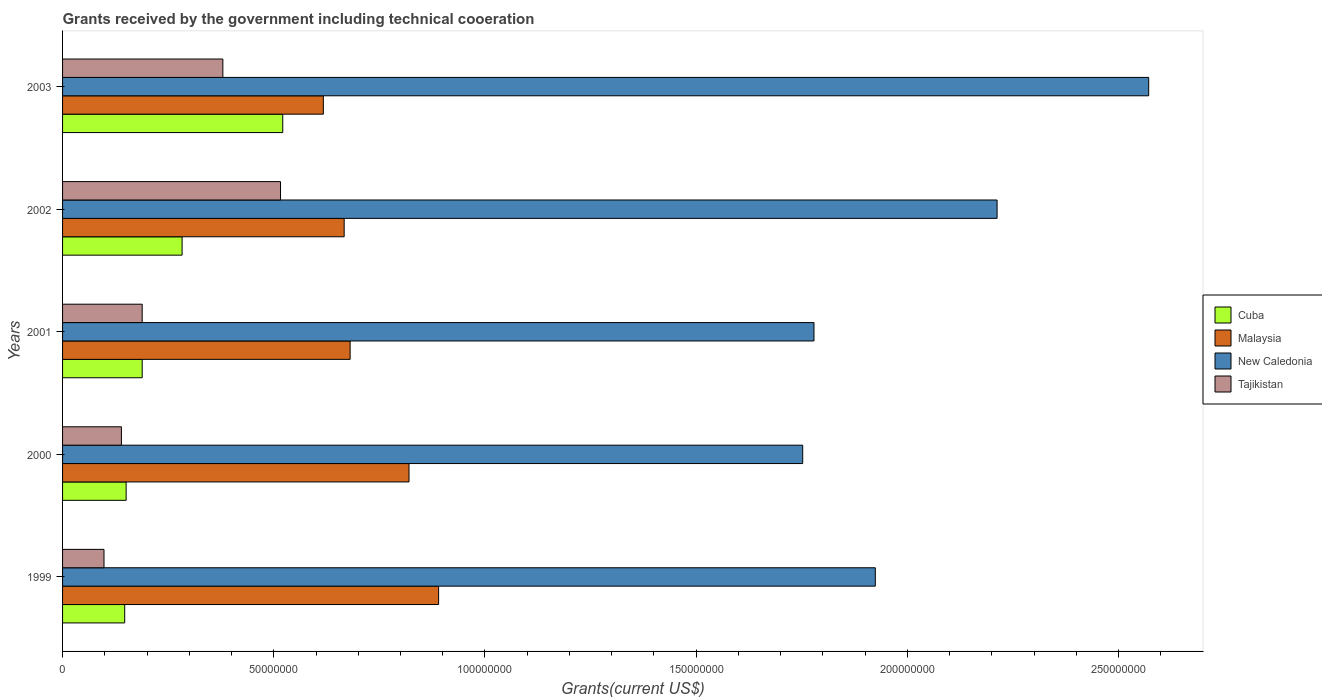How many different coloured bars are there?
Make the answer very short. 4. How many groups of bars are there?
Make the answer very short. 5. Are the number of bars on each tick of the Y-axis equal?
Offer a very short reply. Yes. How many bars are there on the 5th tick from the bottom?
Provide a short and direct response. 4. What is the label of the 4th group of bars from the top?
Your answer should be very brief. 2000. What is the total grants received by the government in New Caledonia in 2002?
Offer a terse response. 2.21e+08. Across all years, what is the maximum total grants received by the government in Tajikistan?
Provide a succinct answer. 5.16e+07. Across all years, what is the minimum total grants received by the government in New Caledonia?
Make the answer very short. 1.75e+08. In which year was the total grants received by the government in New Caledonia maximum?
Offer a terse response. 2003. In which year was the total grants received by the government in Malaysia minimum?
Your answer should be very brief. 2003. What is the total total grants received by the government in Tajikistan in the graph?
Offer a very short reply. 1.32e+08. What is the difference between the total grants received by the government in New Caledonia in 1999 and that in 2002?
Provide a short and direct response. -2.88e+07. What is the difference between the total grants received by the government in Malaysia in 1999 and the total grants received by the government in New Caledonia in 2002?
Your answer should be compact. -1.32e+08. What is the average total grants received by the government in Tajikistan per year?
Provide a succinct answer. 2.64e+07. In the year 1999, what is the difference between the total grants received by the government in Tajikistan and total grants received by the government in Cuba?
Your response must be concise. -4.90e+06. What is the ratio of the total grants received by the government in Tajikistan in 2000 to that in 2002?
Offer a very short reply. 0.27. Is the total grants received by the government in Malaysia in 2001 less than that in 2002?
Provide a succinct answer. No. What is the difference between the highest and the second highest total grants received by the government in Cuba?
Keep it short and to the point. 2.38e+07. What is the difference between the highest and the lowest total grants received by the government in Malaysia?
Keep it short and to the point. 2.73e+07. In how many years, is the total grants received by the government in Cuba greater than the average total grants received by the government in Cuba taken over all years?
Offer a terse response. 2. Is it the case that in every year, the sum of the total grants received by the government in Malaysia and total grants received by the government in New Caledonia is greater than the sum of total grants received by the government in Tajikistan and total grants received by the government in Cuba?
Your answer should be compact. Yes. What does the 1st bar from the top in 2000 represents?
Your answer should be compact. Tajikistan. What does the 4th bar from the bottom in 1999 represents?
Make the answer very short. Tajikistan. What is the difference between two consecutive major ticks on the X-axis?
Make the answer very short. 5.00e+07. What is the title of the graph?
Your answer should be very brief. Grants received by the government including technical cooeration. What is the label or title of the X-axis?
Offer a terse response. Grants(current US$). What is the label or title of the Y-axis?
Provide a succinct answer. Years. What is the Grants(current US$) of Cuba in 1999?
Offer a very short reply. 1.47e+07. What is the Grants(current US$) in Malaysia in 1999?
Offer a terse response. 8.90e+07. What is the Grants(current US$) of New Caledonia in 1999?
Your answer should be compact. 1.92e+08. What is the Grants(current US$) of Tajikistan in 1999?
Your answer should be very brief. 9.81e+06. What is the Grants(current US$) of Cuba in 2000?
Provide a succinct answer. 1.50e+07. What is the Grants(current US$) in Malaysia in 2000?
Give a very brief answer. 8.20e+07. What is the Grants(current US$) of New Caledonia in 2000?
Give a very brief answer. 1.75e+08. What is the Grants(current US$) of Tajikistan in 2000?
Ensure brevity in your answer.  1.39e+07. What is the Grants(current US$) of Cuba in 2001?
Provide a short and direct response. 1.88e+07. What is the Grants(current US$) of Malaysia in 2001?
Provide a short and direct response. 6.81e+07. What is the Grants(current US$) of New Caledonia in 2001?
Offer a terse response. 1.78e+08. What is the Grants(current US$) in Tajikistan in 2001?
Offer a very short reply. 1.88e+07. What is the Grants(current US$) of Cuba in 2002?
Give a very brief answer. 2.83e+07. What is the Grants(current US$) of Malaysia in 2002?
Provide a succinct answer. 6.67e+07. What is the Grants(current US$) in New Caledonia in 2002?
Give a very brief answer. 2.21e+08. What is the Grants(current US$) in Tajikistan in 2002?
Your answer should be compact. 5.16e+07. What is the Grants(current US$) in Cuba in 2003?
Ensure brevity in your answer.  5.21e+07. What is the Grants(current US$) in Malaysia in 2003?
Give a very brief answer. 6.17e+07. What is the Grants(current US$) in New Caledonia in 2003?
Make the answer very short. 2.57e+08. What is the Grants(current US$) in Tajikistan in 2003?
Give a very brief answer. 3.80e+07. Across all years, what is the maximum Grants(current US$) in Cuba?
Your answer should be very brief. 5.21e+07. Across all years, what is the maximum Grants(current US$) in Malaysia?
Provide a short and direct response. 8.90e+07. Across all years, what is the maximum Grants(current US$) of New Caledonia?
Provide a short and direct response. 2.57e+08. Across all years, what is the maximum Grants(current US$) of Tajikistan?
Provide a short and direct response. 5.16e+07. Across all years, what is the minimum Grants(current US$) in Cuba?
Provide a short and direct response. 1.47e+07. Across all years, what is the minimum Grants(current US$) of Malaysia?
Make the answer very short. 6.17e+07. Across all years, what is the minimum Grants(current US$) in New Caledonia?
Offer a very short reply. 1.75e+08. Across all years, what is the minimum Grants(current US$) in Tajikistan?
Provide a succinct answer. 9.81e+06. What is the total Grants(current US$) in Cuba in the graph?
Your answer should be compact. 1.29e+08. What is the total Grants(current US$) in Malaysia in the graph?
Your answer should be very brief. 3.68e+08. What is the total Grants(current US$) of New Caledonia in the graph?
Keep it short and to the point. 1.02e+09. What is the total Grants(current US$) of Tajikistan in the graph?
Provide a succinct answer. 1.32e+08. What is the difference between the Grants(current US$) of Malaysia in 1999 and that in 2000?
Provide a succinct answer. 7.01e+06. What is the difference between the Grants(current US$) of New Caledonia in 1999 and that in 2000?
Offer a very short reply. 1.72e+07. What is the difference between the Grants(current US$) of Tajikistan in 1999 and that in 2000?
Keep it short and to the point. -4.12e+06. What is the difference between the Grants(current US$) of Cuba in 1999 and that in 2001?
Ensure brevity in your answer.  -4.14e+06. What is the difference between the Grants(current US$) in Malaysia in 1999 and that in 2001?
Provide a succinct answer. 2.10e+07. What is the difference between the Grants(current US$) of New Caledonia in 1999 and that in 2001?
Make the answer very short. 1.45e+07. What is the difference between the Grants(current US$) in Tajikistan in 1999 and that in 2001?
Make the answer very short. -9.04e+06. What is the difference between the Grants(current US$) in Cuba in 1999 and that in 2002?
Give a very brief answer. -1.36e+07. What is the difference between the Grants(current US$) in Malaysia in 1999 and that in 2002?
Offer a terse response. 2.24e+07. What is the difference between the Grants(current US$) in New Caledonia in 1999 and that in 2002?
Ensure brevity in your answer.  -2.88e+07. What is the difference between the Grants(current US$) of Tajikistan in 1999 and that in 2002?
Ensure brevity in your answer.  -4.18e+07. What is the difference between the Grants(current US$) of Cuba in 1999 and that in 2003?
Offer a very short reply. -3.74e+07. What is the difference between the Grants(current US$) in Malaysia in 1999 and that in 2003?
Ensure brevity in your answer.  2.73e+07. What is the difference between the Grants(current US$) of New Caledonia in 1999 and that in 2003?
Ensure brevity in your answer.  -6.47e+07. What is the difference between the Grants(current US$) in Tajikistan in 1999 and that in 2003?
Offer a very short reply. -2.81e+07. What is the difference between the Grants(current US$) in Cuba in 2000 and that in 2001?
Provide a succinct answer. -3.80e+06. What is the difference between the Grants(current US$) in Malaysia in 2000 and that in 2001?
Offer a terse response. 1.39e+07. What is the difference between the Grants(current US$) in New Caledonia in 2000 and that in 2001?
Your answer should be compact. -2.67e+06. What is the difference between the Grants(current US$) of Tajikistan in 2000 and that in 2001?
Provide a short and direct response. -4.92e+06. What is the difference between the Grants(current US$) in Cuba in 2000 and that in 2002?
Your answer should be compact. -1.32e+07. What is the difference between the Grants(current US$) in Malaysia in 2000 and that in 2002?
Ensure brevity in your answer.  1.54e+07. What is the difference between the Grants(current US$) in New Caledonia in 2000 and that in 2002?
Your answer should be very brief. -4.60e+07. What is the difference between the Grants(current US$) of Tajikistan in 2000 and that in 2002?
Ensure brevity in your answer.  -3.77e+07. What is the difference between the Grants(current US$) of Cuba in 2000 and that in 2003?
Offer a very short reply. -3.71e+07. What is the difference between the Grants(current US$) of Malaysia in 2000 and that in 2003?
Provide a short and direct response. 2.03e+07. What is the difference between the Grants(current US$) in New Caledonia in 2000 and that in 2003?
Your answer should be very brief. -8.19e+07. What is the difference between the Grants(current US$) in Tajikistan in 2000 and that in 2003?
Provide a short and direct response. -2.40e+07. What is the difference between the Grants(current US$) in Cuba in 2001 and that in 2002?
Your response must be concise. -9.45e+06. What is the difference between the Grants(current US$) of Malaysia in 2001 and that in 2002?
Provide a short and direct response. 1.41e+06. What is the difference between the Grants(current US$) of New Caledonia in 2001 and that in 2002?
Offer a very short reply. -4.34e+07. What is the difference between the Grants(current US$) of Tajikistan in 2001 and that in 2002?
Give a very brief answer. -3.28e+07. What is the difference between the Grants(current US$) of Cuba in 2001 and that in 2003?
Offer a terse response. -3.33e+07. What is the difference between the Grants(current US$) in Malaysia in 2001 and that in 2003?
Your response must be concise. 6.34e+06. What is the difference between the Grants(current US$) of New Caledonia in 2001 and that in 2003?
Your answer should be compact. -7.92e+07. What is the difference between the Grants(current US$) in Tajikistan in 2001 and that in 2003?
Offer a very short reply. -1.91e+07. What is the difference between the Grants(current US$) of Cuba in 2002 and that in 2003?
Ensure brevity in your answer.  -2.38e+07. What is the difference between the Grants(current US$) in Malaysia in 2002 and that in 2003?
Make the answer very short. 4.93e+06. What is the difference between the Grants(current US$) in New Caledonia in 2002 and that in 2003?
Your answer should be compact. -3.59e+07. What is the difference between the Grants(current US$) in Tajikistan in 2002 and that in 2003?
Give a very brief answer. 1.36e+07. What is the difference between the Grants(current US$) of Cuba in 1999 and the Grants(current US$) of Malaysia in 2000?
Give a very brief answer. -6.73e+07. What is the difference between the Grants(current US$) in Cuba in 1999 and the Grants(current US$) in New Caledonia in 2000?
Offer a very short reply. -1.61e+08. What is the difference between the Grants(current US$) of Cuba in 1999 and the Grants(current US$) of Tajikistan in 2000?
Make the answer very short. 7.80e+05. What is the difference between the Grants(current US$) in Malaysia in 1999 and the Grants(current US$) in New Caledonia in 2000?
Provide a short and direct response. -8.62e+07. What is the difference between the Grants(current US$) of Malaysia in 1999 and the Grants(current US$) of Tajikistan in 2000?
Provide a short and direct response. 7.51e+07. What is the difference between the Grants(current US$) in New Caledonia in 1999 and the Grants(current US$) in Tajikistan in 2000?
Give a very brief answer. 1.78e+08. What is the difference between the Grants(current US$) of Cuba in 1999 and the Grants(current US$) of Malaysia in 2001?
Keep it short and to the point. -5.34e+07. What is the difference between the Grants(current US$) of Cuba in 1999 and the Grants(current US$) of New Caledonia in 2001?
Ensure brevity in your answer.  -1.63e+08. What is the difference between the Grants(current US$) of Cuba in 1999 and the Grants(current US$) of Tajikistan in 2001?
Offer a terse response. -4.14e+06. What is the difference between the Grants(current US$) in Malaysia in 1999 and the Grants(current US$) in New Caledonia in 2001?
Give a very brief answer. -8.89e+07. What is the difference between the Grants(current US$) of Malaysia in 1999 and the Grants(current US$) of Tajikistan in 2001?
Offer a terse response. 7.02e+07. What is the difference between the Grants(current US$) of New Caledonia in 1999 and the Grants(current US$) of Tajikistan in 2001?
Provide a succinct answer. 1.74e+08. What is the difference between the Grants(current US$) of Cuba in 1999 and the Grants(current US$) of Malaysia in 2002?
Ensure brevity in your answer.  -5.20e+07. What is the difference between the Grants(current US$) in Cuba in 1999 and the Grants(current US$) in New Caledonia in 2002?
Your answer should be very brief. -2.07e+08. What is the difference between the Grants(current US$) in Cuba in 1999 and the Grants(current US$) in Tajikistan in 2002?
Your answer should be compact. -3.69e+07. What is the difference between the Grants(current US$) of Malaysia in 1999 and the Grants(current US$) of New Caledonia in 2002?
Provide a short and direct response. -1.32e+08. What is the difference between the Grants(current US$) of Malaysia in 1999 and the Grants(current US$) of Tajikistan in 2002?
Offer a very short reply. 3.74e+07. What is the difference between the Grants(current US$) of New Caledonia in 1999 and the Grants(current US$) of Tajikistan in 2002?
Ensure brevity in your answer.  1.41e+08. What is the difference between the Grants(current US$) of Cuba in 1999 and the Grants(current US$) of Malaysia in 2003?
Provide a succinct answer. -4.70e+07. What is the difference between the Grants(current US$) of Cuba in 1999 and the Grants(current US$) of New Caledonia in 2003?
Offer a very short reply. -2.42e+08. What is the difference between the Grants(current US$) of Cuba in 1999 and the Grants(current US$) of Tajikistan in 2003?
Offer a terse response. -2.32e+07. What is the difference between the Grants(current US$) in Malaysia in 1999 and the Grants(current US$) in New Caledonia in 2003?
Offer a terse response. -1.68e+08. What is the difference between the Grants(current US$) of Malaysia in 1999 and the Grants(current US$) of Tajikistan in 2003?
Make the answer very short. 5.11e+07. What is the difference between the Grants(current US$) of New Caledonia in 1999 and the Grants(current US$) of Tajikistan in 2003?
Keep it short and to the point. 1.54e+08. What is the difference between the Grants(current US$) in Cuba in 2000 and the Grants(current US$) in Malaysia in 2001?
Keep it short and to the point. -5.30e+07. What is the difference between the Grants(current US$) of Cuba in 2000 and the Grants(current US$) of New Caledonia in 2001?
Offer a terse response. -1.63e+08. What is the difference between the Grants(current US$) of Cuba in 2000 and the Grants(current US$) of Tajikistan in 2001?
Offer a very short reply. -3.80e+06. What is the difference between the Grants(current US$) of Malaysia in 2000 and the Grants(current US$) of New Caledonia in 2001?
Offer a very short reply. -9.59e+07. What is the difference between the Grants(current US$) in Malaysia in 2000 and the Grants(current US$) in Tajikistan in 2001?
Make the answer very short. 6.32e+07. What is the difference between the Grants(current US$) of New Caledonia in 2000 and the Grants(current US$) of Tajikistan in 2001?
Make the answer very short. 1.56e+08. What is the difference between the Grants(current US$) of Cuba in 2000 and the Grants(current US$) of Malaysia in 2002?
Ensure brevity in your answer.  -5.16e+07. What is the difference between the Grants(current US$) of Cuba in 2000 and the Grants(current US$) of New Caledonia in 2002?
Your answer should be very brief. -2.06e+08. What is the difference between the Grants(current US$) in Cuba in 2000 and the Grants(current US$) in Tajikistan in 2002?
Your response must be concise. -3.66e+07. What is the difference between the Grants(current US$) in Malaysia in 2000 and the Grants(current US$) in New Caledonia in 2002?
Your answer should be compact. -1.39e+08. What is the difference between the Grants(current US$) of Malaysia in 2000 and the Grants(current US$) of Tajikistan in 2002?
Offer a terse response. 3.04e+07. What is the difference between the Grants(current US$) in New Caledonia in 2000 and the Grants(current US$) in Tajikistan in 2002?
Your answer should be very brief. 1.24e+08. What is the difference between the Grants(current US$) in Cuba in 2000 and the Grants(current US$) in Malaysia in 2003?
Provide a succinct answer. -4.67e+07. What is the difference between the Grants(current US$) of Cuba in 2000 and the Grants(current US$) of New Caledonia in 2003?
Provide a succinct answer. -2.42e+08. What is the difference between the Grants(current US$) in Cuba in 2000 and the Grants(current US$) in Tajikistan in 2003?
Your response must be concise. -2.29e+07. What is the difference between the Grants(current US$) of Malaysia in 2000 and the Grants(current US$) of New Caledonia in 2003?
Provide a short and direct response. -1.75e+08. What is the difference between the Grants(current US$) in Malaysia in 2000 and the Grants(current US$) in Tajikistan in 2003?
Provide a short and direct response. 4.41e+07. What is the difference between the Grants(current US$) of New Caledonia in 2000 and the Grants(current US$) of Tajikistan in 2003?
Make the answer very short. 1.37e+08. What is the difference between the Grants(current US$) of Cuba in 2001 and the Grants(current US$) of Malaysia in 2002?
Provide a succinct answer. -4.78e+07. What is the difference between the Grants(current US$) in Cuba in 2001 and the Grants(current US$) in New Caledonia in 2002?
Your response must be concise. -2.02e+08. What is the difference between the Grants(current US$) in Cuba in 2001 and the Grants(current US$) in Tajikistan in 2002?
Your answer should be compact. -3.28e+07. What is the difference between the Grants(current US$) in Malaysia in 2001 and the Grants(current US$) in New Caledonia in 2002?
Provide a short and direct response. -1.53e+08. What is the difference between the Grants(current US$) of Malaysia in 2001 and the Grants(current US$) of Tajikistan in 2002?
Keep it short and to the point. 1.65e+07. What is the difference between the Grants(current US$) of New Caledonia in 2001 and the Grants(current US$) of Tajikistan in 2002?
Your answer should be compact. 1.26e+08. What is the difference between the Grants(current US$) in Cuba in 2001 and the Grants(current US$) in Malaysia in 2003?
Offer a very short reply. -4.29e+07. What is the difference between the Grants(current US$) in Cuba in 2001 and the Grants(current US$) in New Caledonia in 2003?
Your answer should be compact. -2.38e+08. What is the difference between the Grants(current US$) of Cuba in 2001 and the Grants(current US$) of Tajikistan in 2003?
Provide a short and direct response. -1.91e+07. What is the difference between the Grants(current US$) of Malaysia in 2001 and the Grants(current US$) of New Caledonia in 2003?
Make the answer very short. -1.89e+08. What is the difference between the Grants(current US$) of Malaysia in 2001 and the Grants(current US$) of Tajikistan in 2003?
Ensure brevity in your answer.  3.01e+07. What is the difference between the Grants(current US$) of New Caledonia in 2001 and the Grants(current US$) of Tajikistan in 2003?
Give a very brief answer. 1.40e+08. What is the difference between the Grants(current US$) of Cuba in 2002 and the Grants(current US$) of Malaysia in 2003?
Provide a succinct answer. -3.34e+07. What is the difference between the Grants(current US$) in Cuba in 2002 and the Grants(current US$) in New Caledonia in 2003?
Offer a very short reply. -2.29e+08. What is the difference between the Grants(current US$) in Cuba in 2002 and the Grants(current US$) in Tajikistan in 2003?
Provide a succinct answer. -9.65e+06. What is the difference between the Grants(current US$) of Malaysia in 2002 and the Grants(current US$) of New Caledonia in 2003?
Offer a terse response. -1.90e+08. What is the difference between the Grants(current US$) in Malaysia in 2002 and the Grants(current US$) in Tajikistan in 2003?
Keep it short and to the point. 2.87e+07. What is the difference between the Grants(current US$) of New Caledonia in 2002 and the Grants(current US$) of Tajikistan in 2003?
Provide a short and direct response. 1.83e+08. What is the average Grants(current US$) of Cuba per year?
Your answer should be compact. 2.58e+07. What is the average Grants(current US$) in Malaysia per year?
Your response must be concise. 7.35e+07. What is the average Grants(current US$) in New Caledonia per year?
Provide a succinct answer. 2.05e+08. What is the average Grants(current US$) in Tajikistan per year?
Your answer should be very brief. 2.64e+07. In the year 1999, what is the difference between the Grants(current US$) in Cuba and Grants(current US$) in Malaysia?
Offer a very short reply. -7.43e+07. In the year 1999, what is the difference between the Grants(current US$) in Cuba and Grants(current US$) in New Caledonia?
Your answer should be compact. -1.78e+08. In the year 1999, what is the difference between the Grants(current US$) in Cuba and Grants(current US$) in Tajikistan?
Offer a terse response. 4.90e+06. In the year 1999, what is the difference between the Grants(current US$) in Malaysia and Grants(current US$) in New Caledonia?
Ensure brevity in your answer.  -1.03e+08. In the year 1999, what is the difference between the Grants(current US$) in Malaysia and Grants(current US$) in Tajikistan?
Provide a short and direct response. 7.92e+07. In the year 1999, what is the difference between the Grants(current US$) of New Caledonia and Grants(current US$) of Tajikistan?
Keep it short and to the point. 1.83e+08. In the year 2000, what is the difference between the Grants(current US$) in Cuba and Grants(current US$) in Malaysia?
Provide a succinct answer. -6.70e+07. In the year 2000, what is the difference between the Grants(current US$) of Cuba and Grants(current US$) of New Caledonia?
Provide a succinct answer. -1.60e+08. In the year 2000, what is the difference between the Grants(current US$) of Cuba and Grants(current US$) of Tajikistan?
Make the answer very short. 1.12e+06. In the year 2000, what is the difference between the Grants(current US$) of Malaysia and Grants(current US$) of New Caledonia?
Provide a succinct answer. -9.32e+07. In the year 2000, what is the difference between the Grants(current US$) in Malaysia and Grants(current US$) in Tajikistan?
Make the answer very short. 6.81e+07. In the year 2000, what is the difference between the Grants(current US$) of New Caledonia and Grants(current US$) of Tajikistan?
Provide a short and direct response. 1.61e+08. In the year 2001, what is the difference between the Grants(current US$) in Cuba and Grants(current US$) in Malaysia?
Keep it short and to the point. -4.92e+07. In the year 2001, what is the difference between the Grants(current US$) in Cuba and Grants(current US$) in New Caledonia?
Your answer should be very brief. -1.59e+08. In the year 2001, what is the difference between the Grants(current US$) of Malaysia and Grants(current US$) of New Caledonia?
Offer a very short reply. -1.10e+08. In the year 2001, what is the difference between the Grants(current US$) in Malaysia and Grants(current US$) in Tajikistan?
Provide a succinct answer. 4.92e+07. In the year 2001, what is the difference between the Grants(current US$) of New Caledonia and Grants(current US$) of Tajikistan?
Give a very brief answer. 1.59e+08. In the year 2002, what is the difference between the Grants(current US$) of Cuba and Grants(current US$) of Malaysia?
Ensure brevity in your answer.  -3.84e+07. In the year 2002, what is the difference between the Grants(current US$) in Cuba and Grants(current US$) in New Caledonia?
Give a very brief answer. -1.93e+08. In the year 2002, what is the difference between the Grants(current US$) of Cuba and Grants(current US$) of Tajikistan?
Offer a very short reply. -2.33e+07. In the year 2002, what is the difference between the Grants(current US$) of Malaysia and Grants(current US$) of New Caledonia?
Your answer should be compact. -1.55e+08. In the year 2002, what is the difference between the Grants(current US$) of Malaysia and Grants(current US$) of Tajikistan?
Offer a terse response. 1.51e+07. In the year 2002, what is the difference between the Grants(current US$) in New Caledonia and Grants(current US$) in Tajikistan?
Make the answer very short. 1.70e+08. In the year 2003, what is the difference between the Grants(current US$) in Cuba and Grants(current US$) in Malaysia?
Ensure brevity in your answer.  -9.61e+06. In the year 2003, what is the difference between the Grants(current US$) in Cuba and Grants(current US$) in New Caledonia?
Give a very brief answer. -2.05e+08. In the year 2003, what is the difference between the Grants(current US$) in Cuba and Grants(current US$) in Tajikistan?
Ensure brevity in your answer.  1.42e+07. In the year 2003, what is the difference between the Grants(current US$) of Malaysia and Grants(current US$) of New Caledonia?
Give a very brief answer. -1.95e+08. In the year 2003, what is the difference between the Grants(current US$) of Malaysia and Grants(current US$) of Tajikistan?
Your answer should be very brief. 2.38e+07. In the year 2003, what is the difference between the Grants(current US$) in New Caledonia and Grants(current US$) in Tajikistan?
Give a very brief answer. 2.19e+08. What is the ratio of the Grants(current US$) in Cuba in 1999 to that in 2000?
Your answer should be very brief. 0.98. What is the ratio of the Grants(current US$) in Malaysia in 1999 to that in 2000?
Offer a terse response. 1.09. What is the ratio of the Grants(current US$) in New Caledonia in 1999 to that in 2000?
Keep it short and to the point. 1.1. What is the ratio of the Grants(current US$) in Tajikistan in 1999 to that in 2000?
Provide a short and direct response. 0.7. What is the ratio of the Grants(current US$) of Cuba in 1999 to that in 2001?
Give a very brief answer. 0.78. What is the ratio of the Grants(current US$) in Malaysia in 1999 to that in 2001?
Offer a terse response. 1.31. What is the ratio of the Grants(current US$) in New Caledonia in 1999 to that in 2001?
Keep it short and to the point. 1.08. What is the ratio of the Grants(current US$) in Tajikistan in 1999 to that in 2001?
Offer a terse response. 0.52. What is the ratio of the Grants(current US$) of Cuba in 1999 to that in 2002?
Keep it short and to the point. 0.52. What is the ratio of the Grants(current US$) in Malaysia in 1999 to that in 2002?
Make the answer very short. 1.34. What is the ratio of the Grants(current US$) of New Caledonia in 1999 to that in 2002?
Provide a short and direct response. 0.87. What is the ratio of the Grants(current US$) of Tajikistan in 1999 to that in 2002?
Your answer should be very brief. 0.19. What is the ratio of the Grants(current US$) in Cuba in 1999 to that in 2003?
Your answer should be compact. 0.28. What is the ratio of the Grants(current US$) in Malaysia in 1999 to that in 2003?
Give a very brief answer. 1.44. What is the ratio of the Grants(current US$) of New Caledonia in 1999 to that in 2003?
Provide a short and direct response. 0.75. What is the ratio of the Grants(current US$) of Tajikistan in 1999 to that in 2003?
Your response must be concise. 0.26. What is the ratio of the Grants(current US$) of Cuba in 2000 to that in 2001?
Give a very brief answer. 0.8. What is the ratio of the Grants(current US$) of Malaysia in 2000 to that in 2001?
Your response must be concise. 1.2. What is the ratio of the Grants(current US$) in Tajikistan in 2000 to that in 2001?
Provide a succinct answer. 0.74. What is the ratio of the Grants(current US$) of Cuba in 2000 to that in 2002?
Your answer should be very brief. 0.53. What is the ratio of the Grants(current US$) of Malaysia in 2000 to that in 2002?
Offer a terse response. 1.23. What is the ratio of the Grants(current US$) in New Caledonia in 2000 to that in 2002?
Provide a short and direct response. 0.79. What is the ratio of the Grants(current US$) in Tajikistan in 2000 to that in 2002?
Give a very brief answer. 0.27. What is the ratio of the Grants(current US$) of Cuba in 2000 to that in 2003?
Offer a very short reply. 0.29. What is the ratio of the Grants(current US$) in Malaysia in 2000 to that in 2003?
Provide a short and direct response. 1.33. What is the ratio of the Grants(current US$) in New Caledonia in 2000 to that in 2003?
Keep it short and to the point. 0.68. What is the ratio of the Grants(current US$) of Tajikistan in 2000 to that in 2003?
Provide a short and direct response. 0.37. What is the ratio of the Grants(current US$) of Cuba in 2001 to that in 2002?
Your answer should be very brief. 0.67. What is the ratio of the Grants(current US$) in Malaysia in 2001 to that in 2002?
Your response must be concise. 1.02. What is the ratio of the Grants(current US$) of New Caledonia in 2001 to that in 2002?
Your response must be concise. 0.8. What is the ratio of the Grants(current US$) of Tajikistan in 2001 to that in 2002?
Keep it short and to the point. 0.37. What is the ratio of the Grants(current US$) in Cuba in 2001 to that in 2003?
Give a very brief answer. 0.36. What is the ratio of the Grants(current US$) of Malaysia in 2001 to that in 2003?
Keep it short and to the point. 1.1. What is the ratio of the Grants(current US$) in New Caledonia in 2001 to that in 2003?
Offer a very short reply. 0.69. What is the ratio of the Grants(current US$) in Tajikistan in 2001 to that in 2003?
Your response must be concise. 0.5. What is the ratio of the Grants(current US$) of Cuba in 2002 to that in 2003?
Provide a short and direct response. 0.54. What is the ratio of the Grants(current US$) in Malaysia in 2002 to that in 2003?
Provide a succinct answer. 1.08. What is the ratio of the Grants(current US$) in New Caledonia in 2002 to that in 2003?
Your response must be concise. 0.86. What is the ratio of the Grants(current US$) in Tajikistan in 2002 to that in 2003?
Keep it short and to the point. 1.36. What is the difference between the highest and the second highest Grants(current US$) of Cuba?
Give a very brief answer. 2.38e+07. What is the difference between the highest and the second highest Grants(current US$) in Malaysia?
Provide a succinct answer. 7.01e+06. What is the difference between the highest and the second highest Grants(current US$) in New Caledonia?
Your response must be concise. 3.59e+07. What is the difference between the highest and the second highest Grants(current US$) in Tajikistan?
Provide a short and direct response. 1.36e+07. What is the difference between the highest and the lowest Grants(current US$) of Cuba?
Provide a succinct answer. 3.74e+07. What is the difference between the highest and the lowest Grants(current US$) of Malaysia?
Your answer should be very brief. 2.73e+07. What is the difference between the highest and the lowest Grants(current US$) of New Caledonia?
Ensure brevity in your answer.  8.19e+07. What is the difference between the highest and the lowest Grants(current US$) in Tajikistan?
Ensure brevity in your answer.  4.18e+07. 